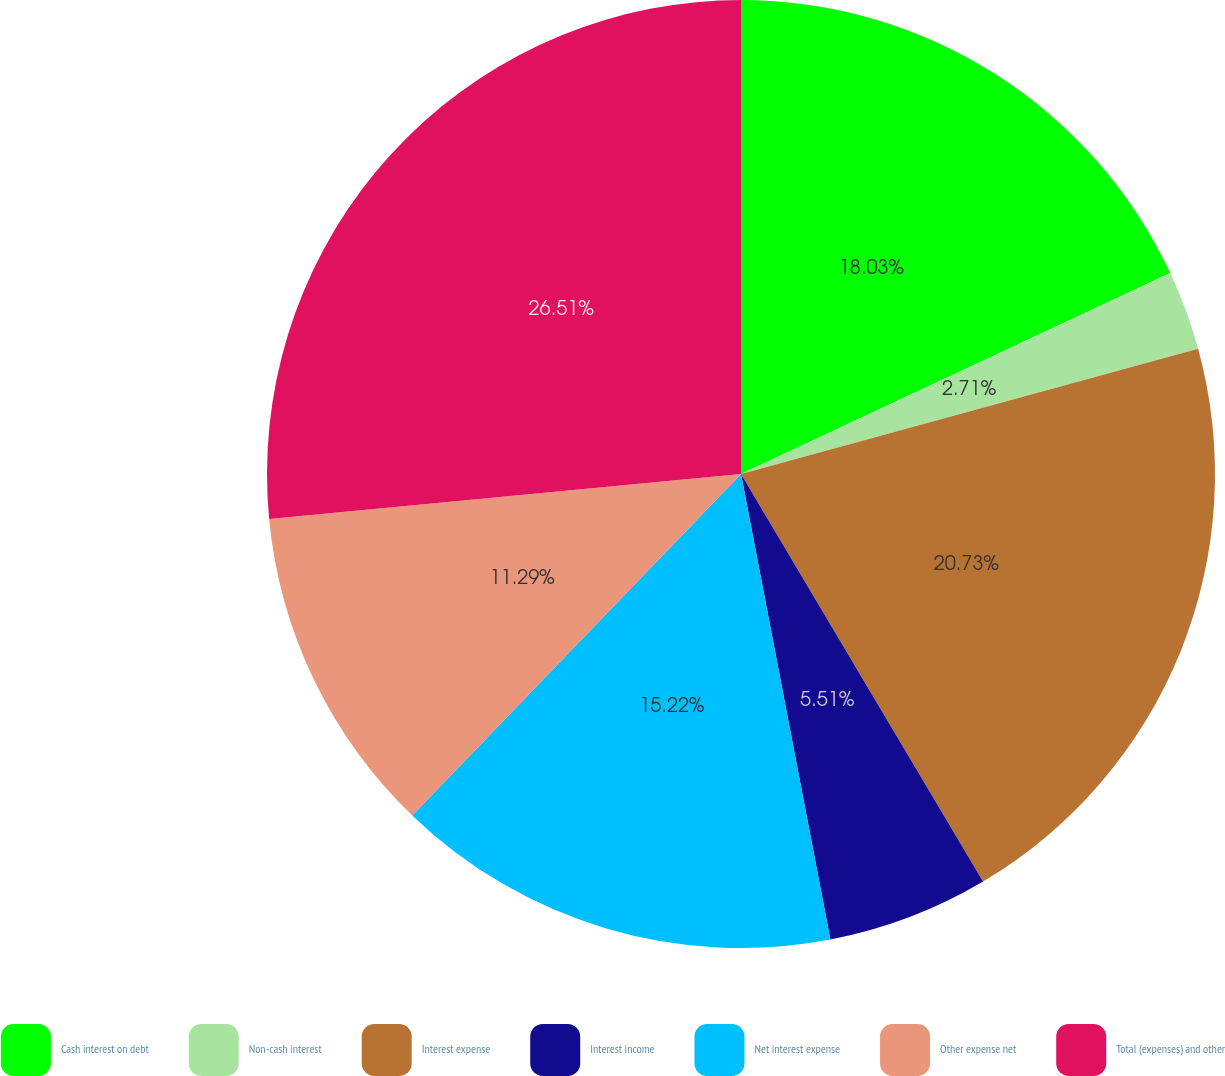Convert chart to OTSL. <chart><loc_0><loc_0><loc_500><loc_500><pie_chart><fcel>Cash interest on debt<fcel>Non-cash interest<fcel>Interest expense<fcel>Interest income<fcel>Net interest expense<fcel>Other expense net<fcel>Total (expenses) and other<nl><fcel>18.03%<fcel>2.71%<fcel>20.73%<fcel>5.51%<fcel>15.22%<fcel>11.29%<fcel>26.51%<nl></chart> 